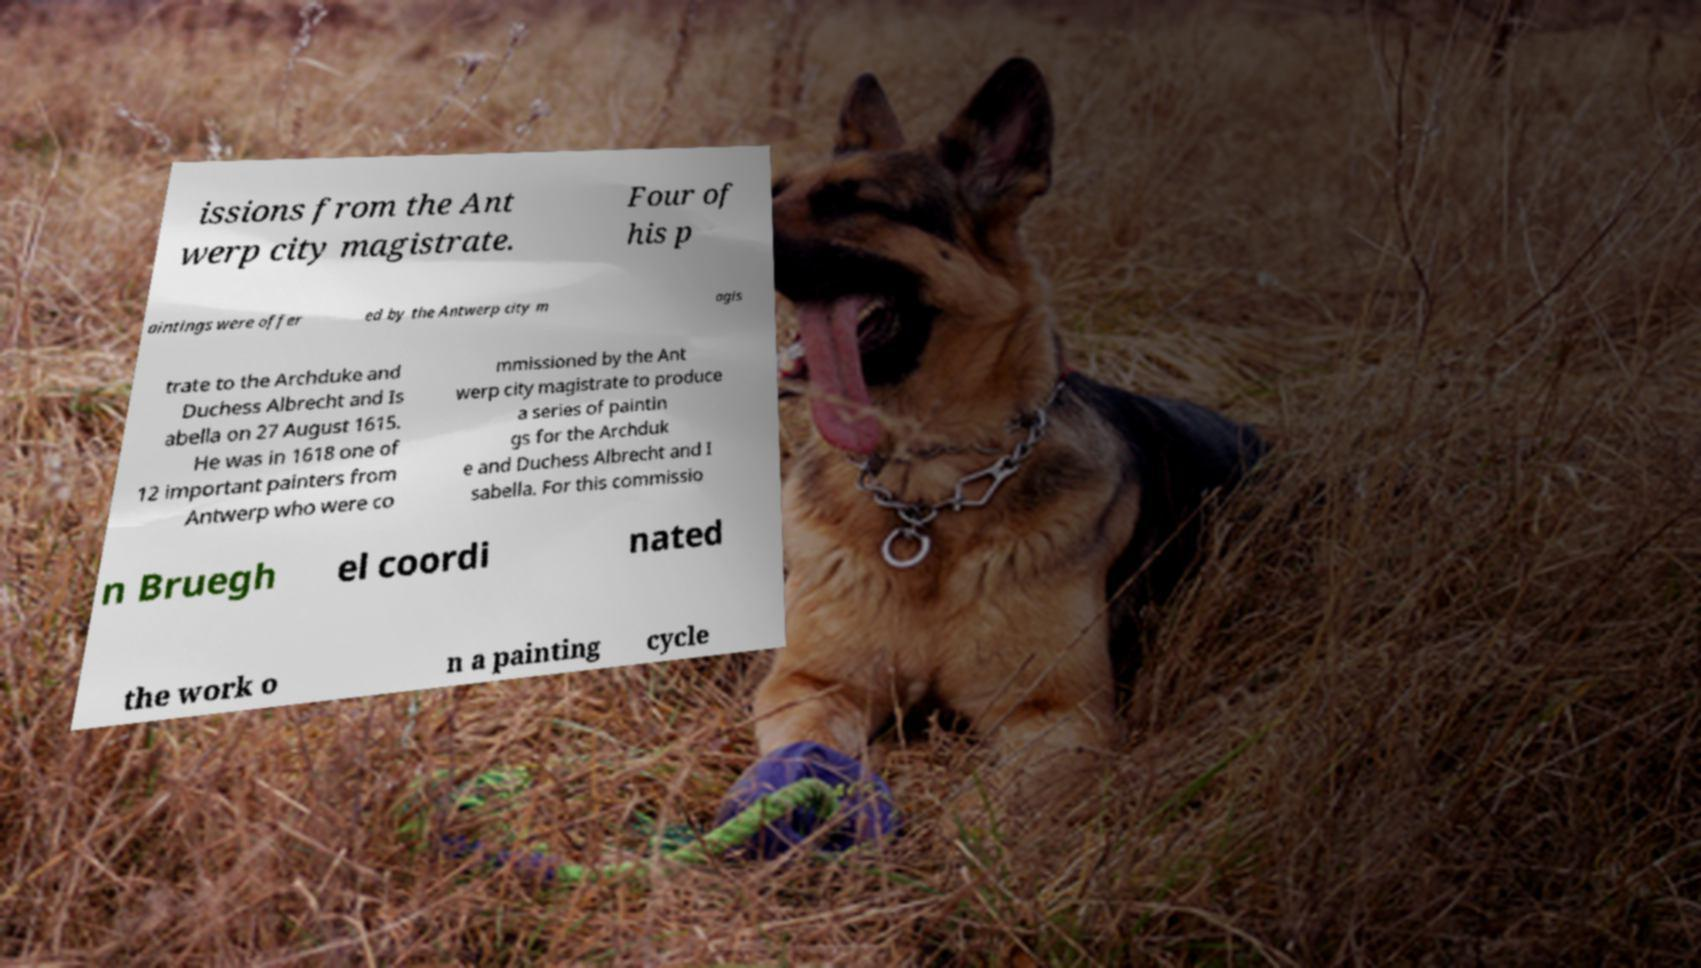I need the written content from this picture converted into text. Can you do that? issions from the Ant werp city magistrate. Four of his p aintings were offer ed by the Antwerp city m agis trate to the Archduke and Duchess Albrecht and Is abella on 27 August 1615. He was in 1618 one of 12 important painters from Antwerp who were co mmissioned by the Ant werp city magistrate to produce a series of paintin gs for the Archduk e and Duchess Albrecht and I sabella. For this commissio n Bruegh el coordi nated the work o n a painting cycle 